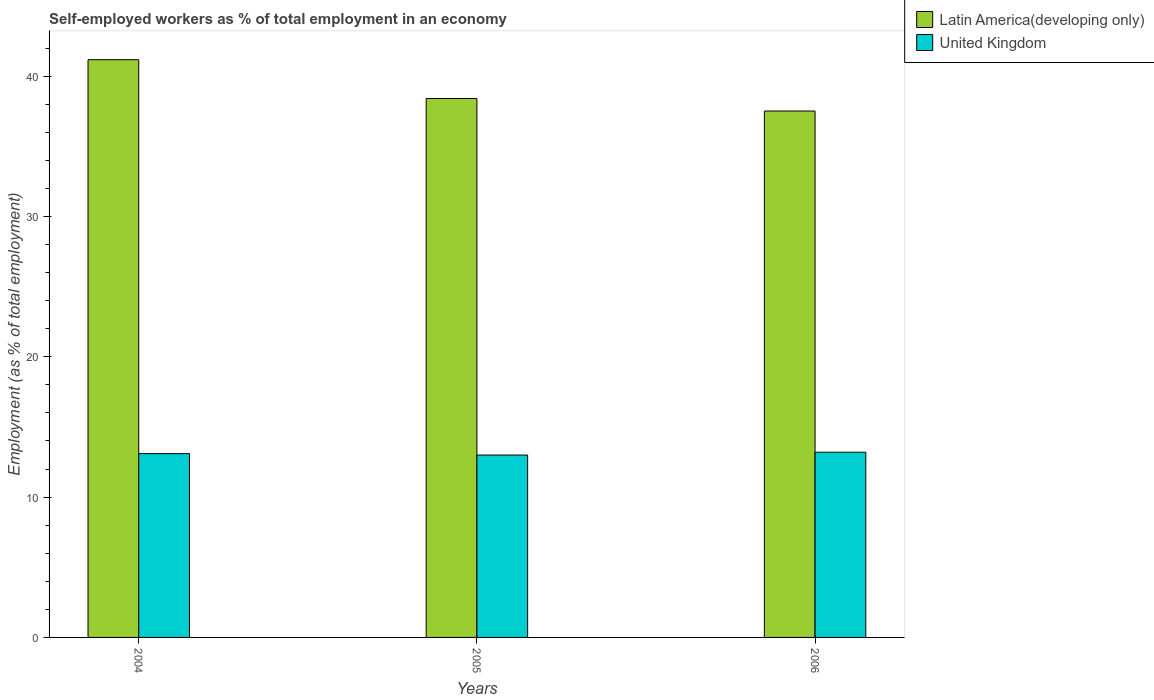Are the number of bars on each tick of the X-axis equal?
Offer a very short reply. Yes. How many bars are there on the 2nd tick from the left?
Give a very brief answer. 2. In how many cases, is the number of bars for a given year not equal to the number of legend labels?
Provide a short and direct response. 0. What is the percentage of self-employed workers in Latin America(developing only) in 2004?
Give a very brief answer. 41.17. Across all years, what is the maximum percentage of self-employed workers in Latin America(developing only)?
Your answer should be very brief. 41.17. Across all years, what is the minimum percentage of self-employed workers in Latin America(developing only)?
Ensure brevity in your answer.  37.52. In which year was the percentage of self-employed workers in Latin America(developing only) minimum?
Provide a succinct answer. 2006. What is the total percentage of self-employed workers in United Kingdom in the graph?
Provide a succinct answer. 39.3. What is the difference between the percentage of self-employed workers in Latin America(developing only) in 2004 and that in 2005?
Ensure brevity in your answer.  2.76. What is the difference between the percentage of self-employed workers in Latin America(developing only) in 2006 and the percentage of self-employed workers in United Kingdom in 2004?
Your answer should be very brief. 24.42. What is the average percentage of self-employed workers in United Kingdom per year?
Your response must be concise. 13.1. In the year 2005, what is the difference between the percentage of self-employed workers in Latin America(developing only) and percentage of self-employed workers in United Kingdom?
Offer a terse response. 25.41. What is the ratio of the percentage of self-employed workers in Latin America(developing only) in 2004 to that in 2005?
Ensure brevity in your answer.  1.07. Is the percentage of self-employed workers in United Kingdom in 2005 less than that in 2006?
Give a very brief answer. Yes. What is the difference between the highest and the second highest percentage of self-employed workers in United Kingdom?
Your answer should be very brief. 0.1. What is the difference between the highest and the lowest percentage of self-employed workers in Latin America(developing only)?
Offer a very short reply. 3.66. In how many years, is the percentage of self-employed workers in United Kingdom greater than the average percentage of self-employed workers in United Kingdom taken over all years?
Give a very brief answer. 2. Is the sum of the percentage of self-employed workers in United Kingdom in 2004 and 2006 greater than the maximum percentage of self-employed workers in Latin America(developing only) across all years?
Ensure brevity in your answer.  No. What does the 1st bar from the left in 2006 represents?
Ensure brevity in your answer.  Latin America(developing only). What does the 2nd bar from the right in 2006 represents?
Offer a very short reply. Latin America(developing only). How many years are there in the graph?
Provide a short and direct response. 3. Are the values on the major ticks of Y-axis written in scientific E-notation?
Give a very brief answer. No. Does the graph contain grids?
Your answer should be very brief. No. How many legend labels are there?
Give a very brief answer. 2. How are the legend labels stacked?
Ensure brevity in your answer.  Vertical. What is the title of the graph?
Your answer should be compact. Self-employed workers as % of total employment in an economy. What is the label or title of the Y-axis?
Ensure brevity in your answer.  Employment (as % of total employment). What is the Employment (as % of total employment) of Latin America(developing only) in 2004?
Keep it short and to the point. 41.17. What is the Employment (as % of total employment) of United Kingdom in 2004?
Provide a succinct answer. 13.1. What is the Employment (as % of total employment) of Latin America(developing only) in 2005?
Keep it short and to the point. 38.41. What is the Employment (as % of total employment) of Latin America(developing only) in 2006?
Your answer should be compact. 37.52. What is the Employment (as % of total employment) in United Kingdom in 2006?
Your response must be concise. 13.2. Across all years, what is the maximum Employment (as % of total employment) of Latin America(developing only)?
Your answer should be very brief. 41.17. Across all years, what is the maximum Employment (as % of total employment) in United Kingdom?
Offer a very short reply. 13.2. Across all years, what is the minimum Employment (as % of total employment) of Latin America(developing only)?
Make the answer very short. 37.52. Across all years, what is the minimum Employment (as % of total employment) of United Kingdom?
Your answer should be very brief. 13. What is the total Employment (as % of total employment) of Latin America(developing only) in the graph?
Offer a terse response. 117.1. What is the total Employment (as % of total employment) in United Kingdom in the graph?
Provide a succinct answer. 39.3. What is the difference between the Employment (as % of total employment) in Latin America(developing only) in 2004 and that in 2005?
Your response must be concise. 2.76. What is the difference between the Employment (as % of total employment) in United Kingdom in 2004 and that in 2005?
Your response must be concise. 0.1. What is the difference between the Employment (as % of total employment) in Latin America(developing only) in 2004 and that in 2006?
Keep it short and to the point. 3.66. What is the difference between the Employment (as % of total employment) in United Kingdom in 2004 and that in 2006?
Give a very brief answer. -0.1. What is the difference between the Employment (as % of total employment) of Latin America(developing only) in 2005 and that in 2006?
Provide a succinct answer. 0.89. What is the difference between the Employment (as % of total employment) in Latin America(developing only) in 2004 and the Employment (as % of total employment) in United Kingdom in 2005?
Your answer should be very brief. 28.17. What is the difference between the Employment (as % of total employment) of Latin America(developing only) in 2004 and the Employment (as % of total employment) of United Kingdom in 2006?
Your answer should be very brief. 27.97. What is the difference between the Employment (as % of total employment) in Latin America(developing only) in 2005 and the Employment (as % of total employment) in United Kingdom in 2006?
Your answer should be very brief. 25.21. What is the average Employment (as % of total employment) in Latin America(developing only) per year?
Offer a very short reply. 39.03. What is the average Employment (as % of total employment) in United Kingdom per year?
Offer a terse response. 13.1. In the year 2004, what is the difference between the Employment (as % of total employment) in Latin America(developing only) and Employment (as % of total employment) in United Kingdom?
Make the answer very short. 28.07. In the year 2005, what is the difference between the Employment (as % of total employment) of Latin America(developing only) and Employment (as % of total employment) of United Kingdom?
Provide a succinct answer. 25.41. In the year 2006, what is the difference between the Employment (as % of total employment) of Latin America(developing only) and Employment (as % of total employment) of United Kingdom?
Ensure brevity in your answer.  24.32. What is the ratio of the Employment (as % of total employment) of Latin America(developing only) in 2004 to that in 2005?
Your answer should be very brief. 1.07. What is the ratio of the Employment (as % of total employment) in United Kingdom in 2004 to that in 2005?
Keep it short and to the point. 1.01. What is the ratio of the Employment (as % of total employment) of Latin America(developing only) in 2004 to that in 2006?
Offer a terse response. 1.1. What is the ratio of the Employment (as % of total employment) in United Kingdom in 2004 to that in 2006?
Provide a succinct answer. 0.99. What is the ratio of the Employment (as % of total employment) in Latin America(developing only) in 2005 to that in 2006?
Offer a very short reply. 1.02. What is the ratio of the Employment (as % of total employment) of United Kingdom in 2005 to that in 2006?
Provide a short and direct response. 0.98. What is the difference between the highest and the second highest Employment (as % of total employment) in Latin America(developing only)?
Make the answer very short. 2.76. What is the difference between the highest and the lowest Employment (as % of total employment) in Latin America(developing only)?
Give a very brief answer. 3.66. 